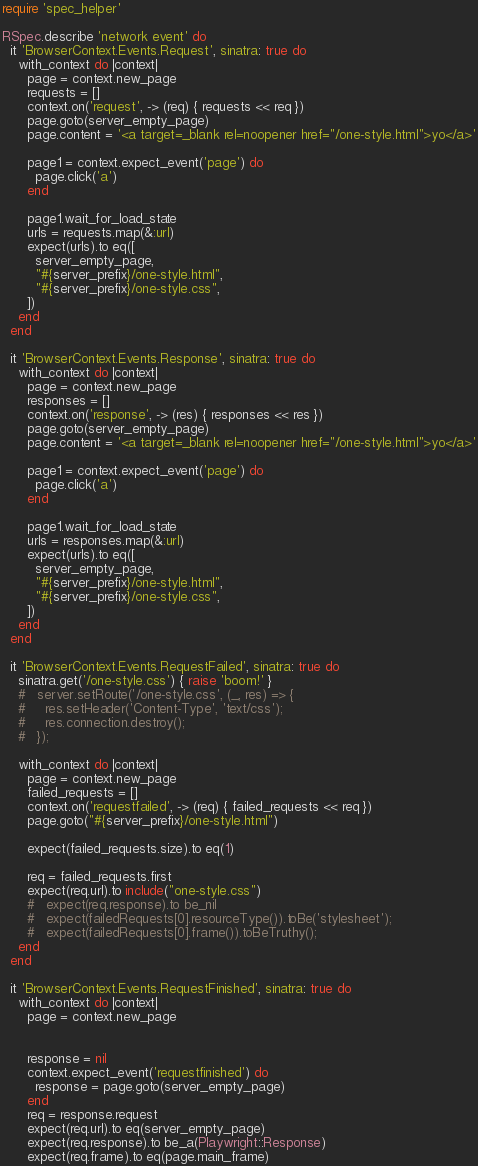Convert code to text. <code><loc_0><loc_0><loc_500><loc_500><_Ruby_>require 'spec_helper'

RSpec.describe 'network event' do
  it 'BrowserContext.Events.Request', sinatra: true do
    with_context do |context|
      page = context.new_page
      requests = []
      context.on('request', -> (req) { requests << req })
      page.goto(server_empty_page)
      page.content = '<a target=_blank rel=noopener href="/one-style.html">yo</a>'

      page1 = context.expect_event('page') do
        page.click('a')
      end

      page1.wait_for_load_state
      urls = requests.map(&:url)
      expect(urls).to eq([
        server_empty_page,
        "#{server_prefix}/one-style.html",
        "#{server_prefix}/one-style.css",
      ])
    end
  end

  it 'BrowserContext.Events.Response', sinatra: true do
    with_context do |context|
      page = context.new_page
      responses = []
      context.on('response', -> (res) { responses << res })
      page.goto(server_empty_page)
      page.content = '<a target=_blank rel=noopener href="/one-style.html">yo</a>'

      page1 = context.expect_event('page') do
        page.click('a')
      end

      page1.wait_for_load_state
      urls = responses.map(&:url)
      expect(urls).to eq([
        server_empty_page,
        "#{server_prefix}/one-style.html",
        "#{server_prefix}/one-style.css",
      ])
    end
  end

  it 'BrowserContext.Events.RequestFailed', sinatra: true do
    sinatra.get('/one-style.css') { raise 'boom!' }
    #   server.setRoute('/one-style.css', (_, res) => {
    #     res.setHeader('Content-Type', 'text/css');
    #     res.connection.destroy();
    #   });

    with_context do |context|
      page = context.new_page
      failed_requests = []
      context.on('requestfailed', -> (req) { failed_requests << req })
      page.goto("#{server_prefix}/one-style.html")

      expect(failed_requests.size).to eq(1)

      req = failed_requests.first
      expect(req.url).to include("one-style.css")
      #   expect(req.response).to be_nil
      #   expect(failedRequests[0].resourceType()).toBe('stylesheet');
      #   expect(failedRequests[0].frame()).toBeTruthy();
    end
  end

  it 'BrowserContext.Events.RequestFinished', sinatra: true do
    with_context do |context|
      page = context.new_page


      response = nil
      context.expect_event('requestfinished') do
        response = page.goto(server_empty_page)
      end
      req = response.request
      expect(req.url).to eq(server_empty_page)
      expect(req.response).to be_a(Playwright::Response)
      expect(req.frame).to eq(page.main_frame)</code> 